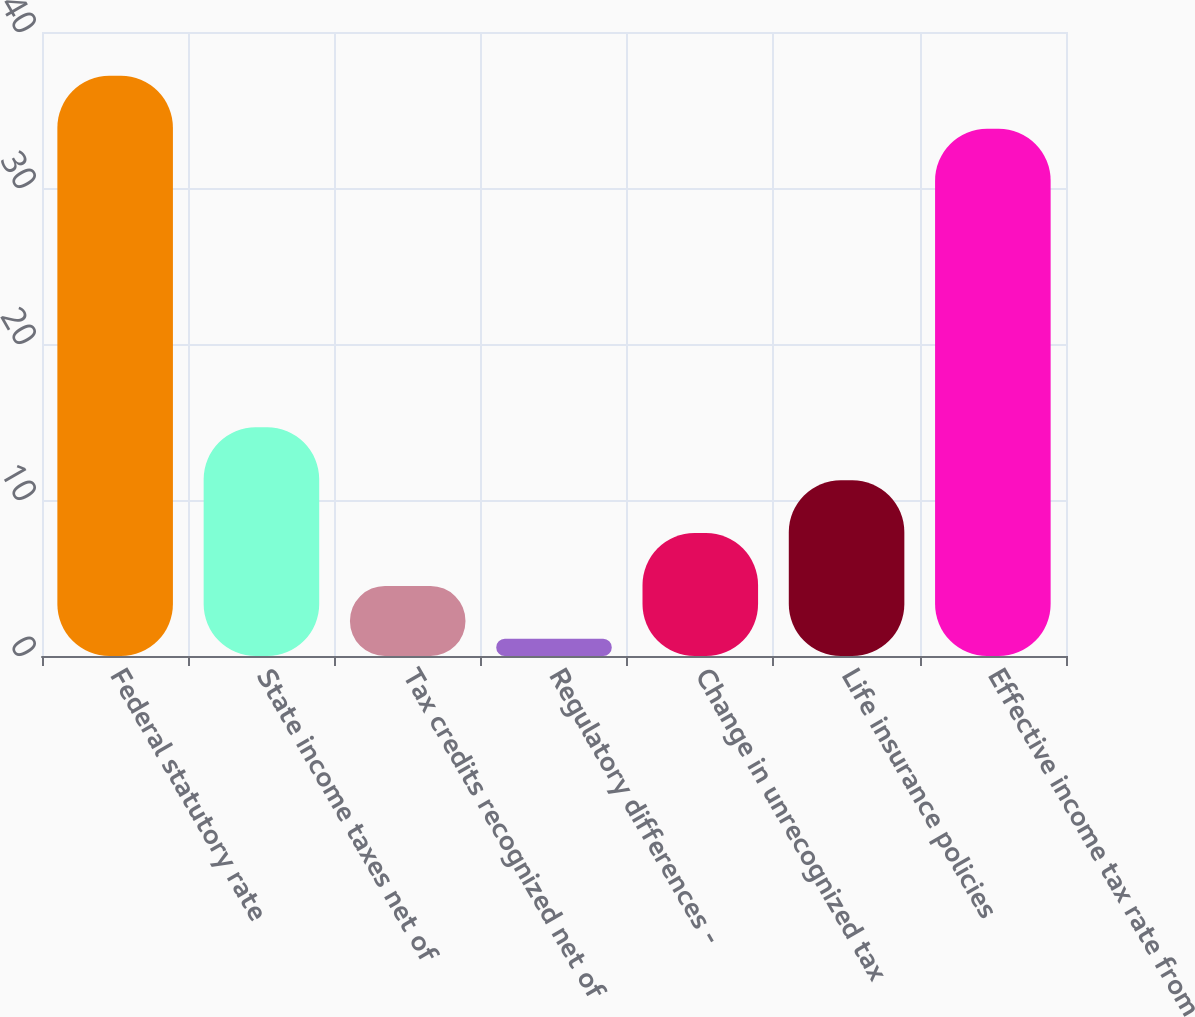Convert chart to OTSL. <chart><loc_0><loc_0><loc_500><loc_500><bar_chart><fcel>Federal statutory rate<fcel>State income taxes net of<fcel>Tax credits recognized net of<fcel>Regulatory differences -<fcel>Change in unrecognized tax<fcel>Life insurance policies<fcel>Effective income tax rate from<nl><fcel>37.19<fcel>14.66<fcel>4.49<fcel>1.1<fcel>7.88<fcel>11.27<fcel>33.8<nl></chart> 